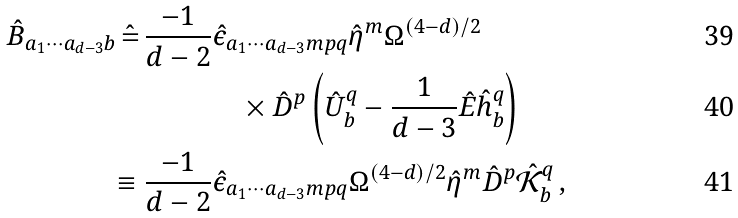Convert formula to latex. <formula><loc_0><loc_0><loc_500><loc_500>\, \hat { B } _ { a _ { 1 } \cdots a _ { d - 3 } b } \, \hat { = } \, \frac { - 1 } { d - 2 } & \hat { \epsilon } _ { a _ { 1 } \cdots a _ { d - 3 } m p q } \hat { \eta } ^ { m } \Omega ^ { ( 4 - d ) / 2 } \\ & \quad \times \hat { D } ^ { p } \left ( \hat { U } ^ { q } _ { b } - \frac { 1 } { d - 3 } \hat { E } \hat { h } ^ { q } _ { b } \right ) \\ \equiv \frac { - 1 } { d - 2 } & \hat { \epsilon } _ { a _ { 1 } \cdots a _ { d - 3 } m p q } \Omega ^ { ( 4 - d ) / 2 } \hat { \eta } ^ { m } \hat { D } ^ { p } \hat { \mathcal { K } } ^ { q } _ { b } \, ,</formula> 